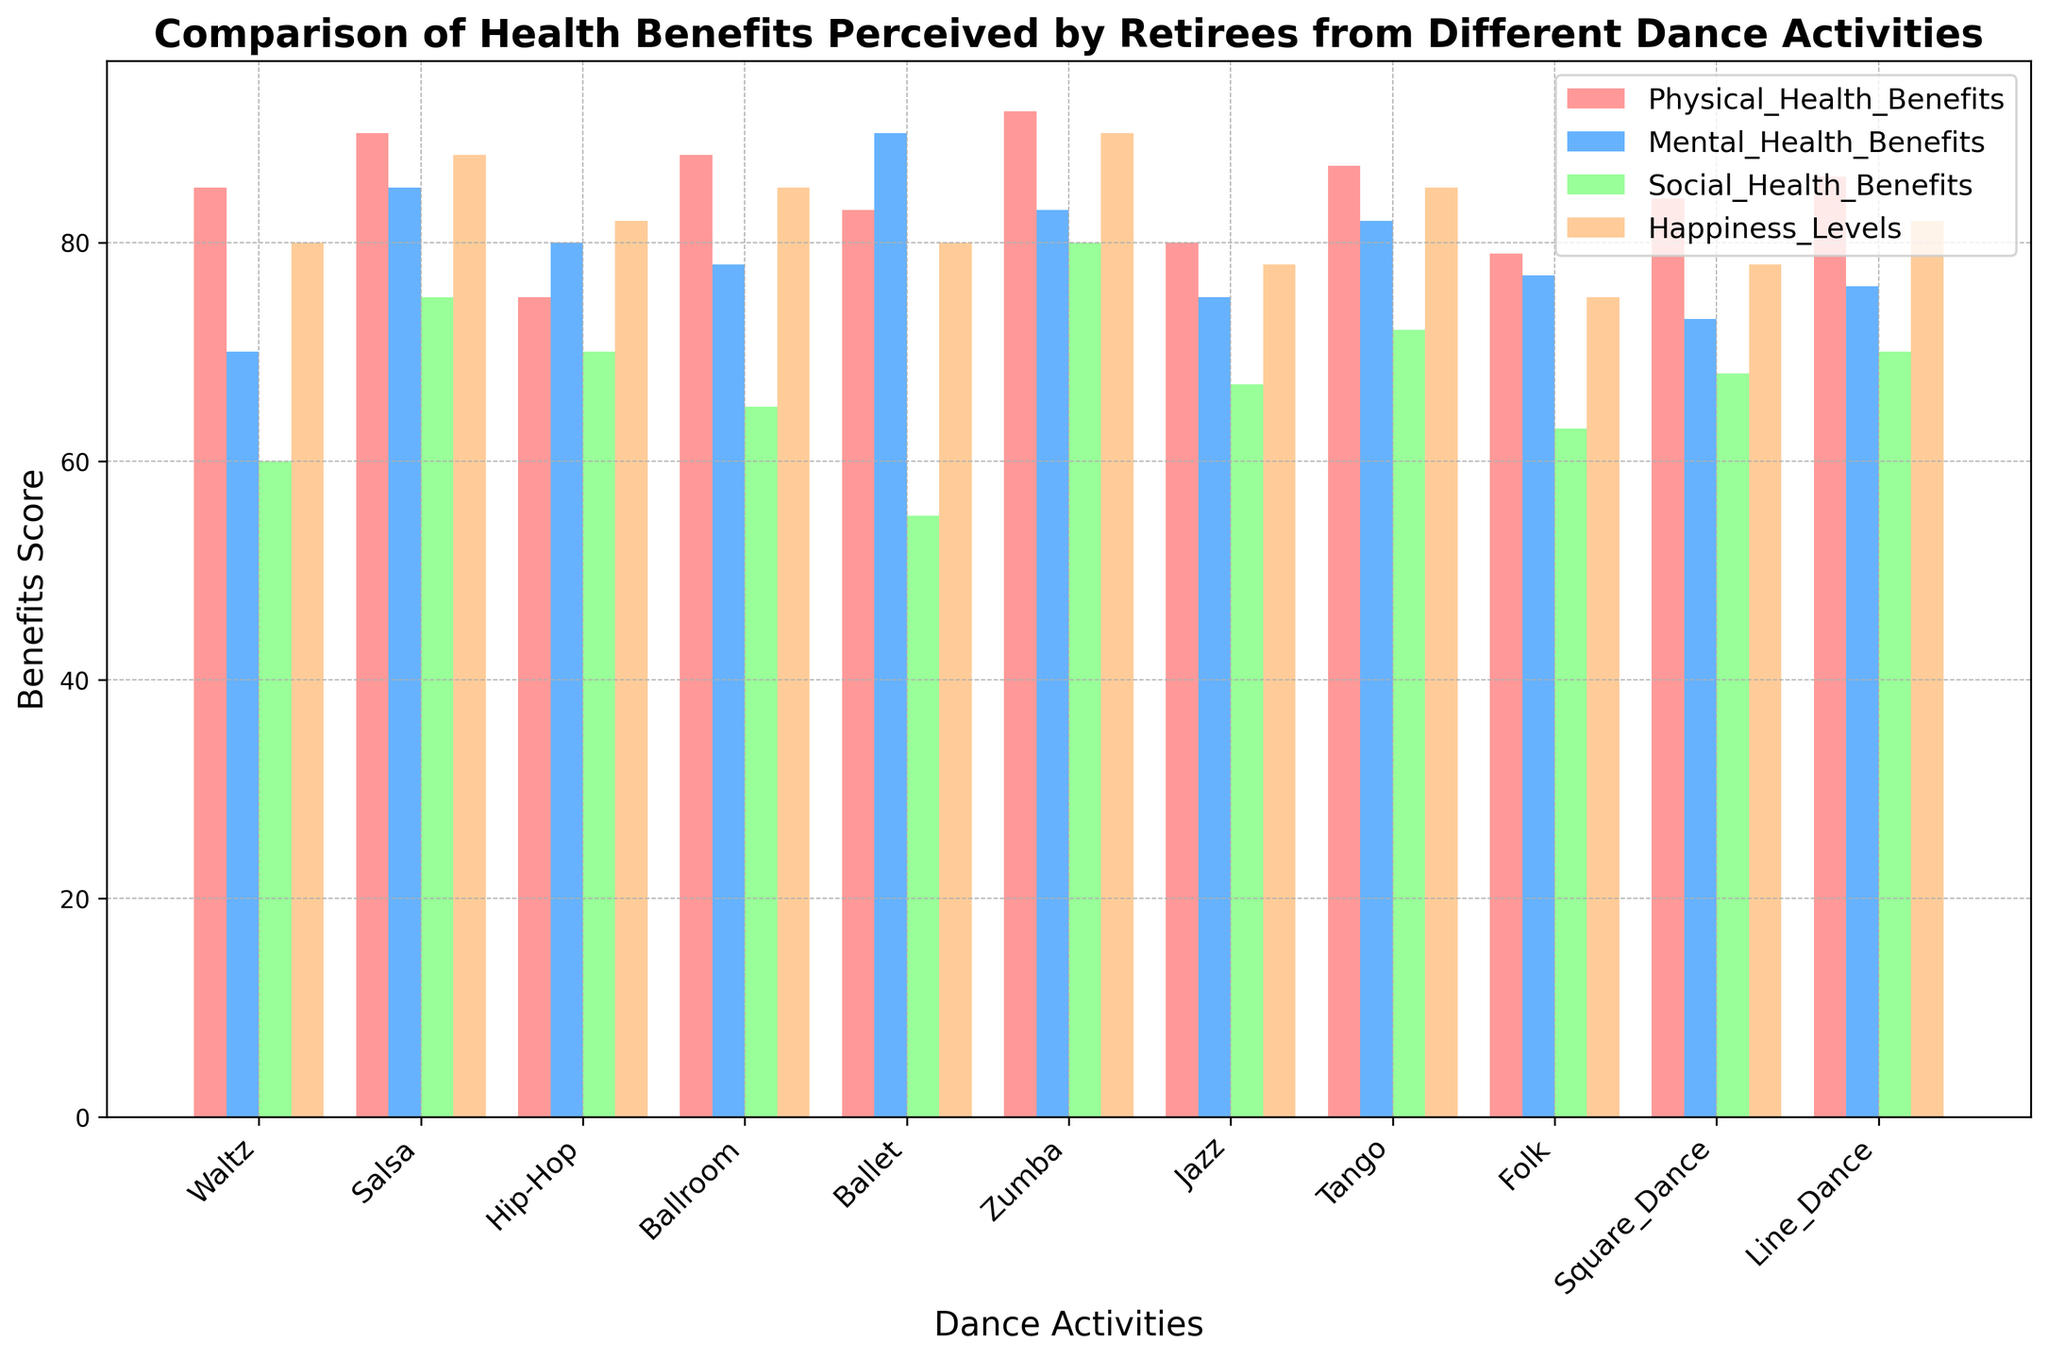Which dance activity has the highest perceived physical health benefits? Looking at the bars representing physical health benefits (most likely the leftmost bars in each group), Zumba has the tallest bar.
Answer: Zumba Which dance activity ranks lowest in social health benefits? Focus on the third set of bars in each group, which represents social health benefits. Ballet has the shortest bar.
Answer: Ballet What is the average mental health benefit score across all dance activities? Add up all the mental health benefit scores: 70 (Waltz) + 85 (Salsa) + 80 (Hip-Hop) + 78 (Ballroom) + 90 (Ballet) + 83 (Zumba) + 75 (Jazz) + 82 (Tango) + 77 (Folk) + 73 (Square_Dance) + 76 (Line_Dance) = 869. Then, divide by the number of dance activities: 869 / 11.
Answer: 79 Which two dance activities show the closest scores in happiness levels? Compare the fourth set of bars. Ballroom and Tango both have similar heights indicating scores close to 85.
Answer: Ballroom and Tango Is there any dance activity that scores consistently high across all benefits categories? Salsa and Zumba both have consistently high bars across physical, mental, social health benefits, and happiness levels. Both show high benefits in all areas with Zumba slightly having higher scores.
Answer: Zumba Which health benefit category shows the largest range in scores across different dance activities? Compare the range (difference between highest and lowest scores) for each category. Physical health benefits range from 75 (Hip-Hop) to 92 (Zumba), which is a range of 17. Mental health benefits range from 70 (Waltz) to 90 (Ballet), which is a range of 20. Social health benefits range from 55 (Ballet) to 80 (Zumba), which is a range of 25. Happiness levels range from 75 (Folk) to 90 (Zumba), which is a range of 15.
Answer: Social Health Benefits If you sum all the happiness levels, what is the total score? Add up all happiness level scores: 80 (Waltz) + 88 (Salsa) + 82 (Hip-Hop) + 85 (Ballroom) + 80 (Ballet) + 90 (Zumba) + 78 (Jazz) + 85 (Tango) + 75 (Folk) + 78 (Square Dance) + 82 (Line Dance). The total is: 883.
Answer: 883 